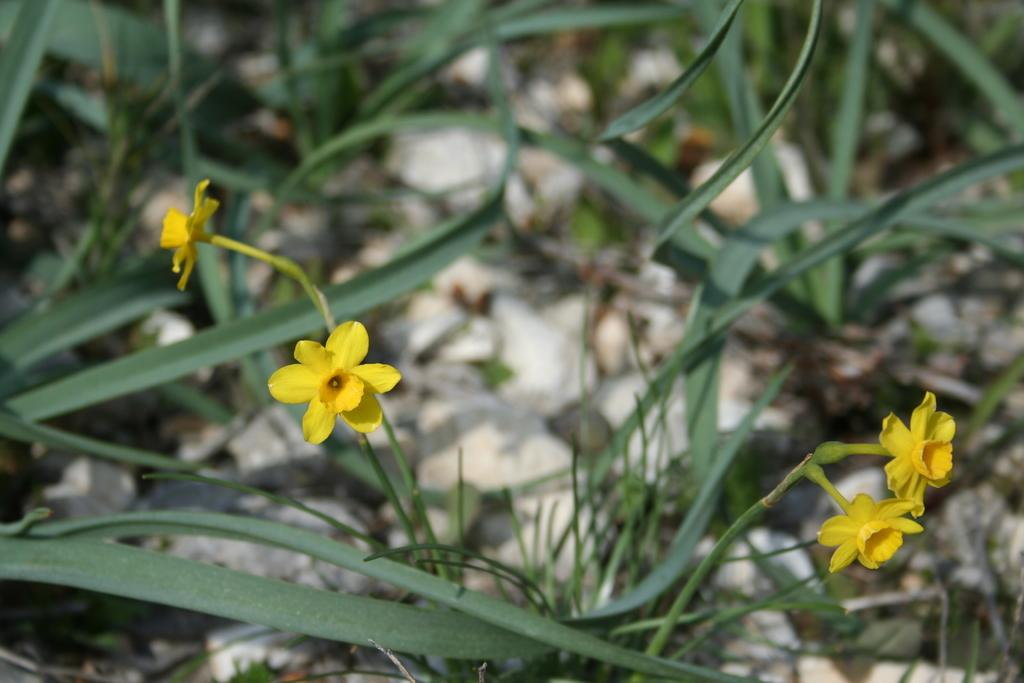What type of living organisms can be seen in the image? There are flowers and plants visible in the image. Can you describe the plants in the image? The plants in the image are not specified, but they are likely green and have leaves. How many types of living organisms are present in the image? There are two types of living organisms present in the image: flowers and plants. What color are the snails' ears in the image? There are no snails or ears present in the image; it only features flowers and plants. 